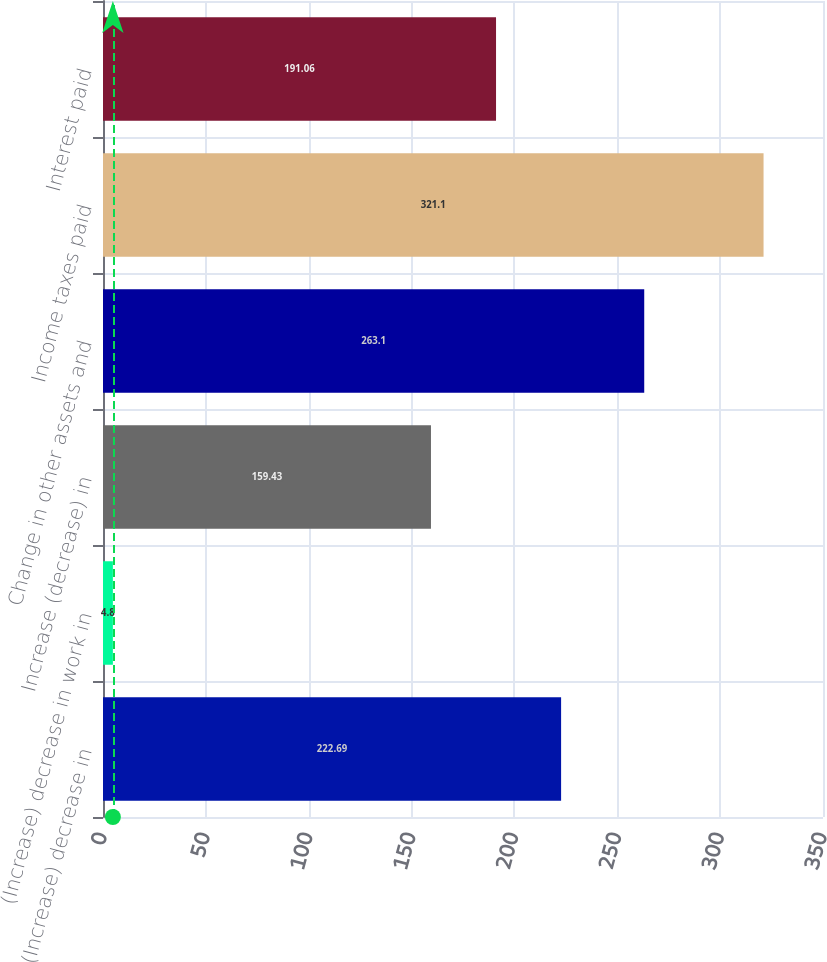<chart> <loc_0><loc_0><loc_500><loc_500><bar_chart><fcel>(Increase) decrease in<fcel>(Increase) decrease in work in<fcel>Increase (decrease) in<fcel>Change in other assets and<fcel>Income taxes paid<fcel>Interest paid<nl><fcel>222.69<fcel>4.8<fcel>159.43<fcel>263.1<fcel>321.1<fcel>191.06<nl></chart> 